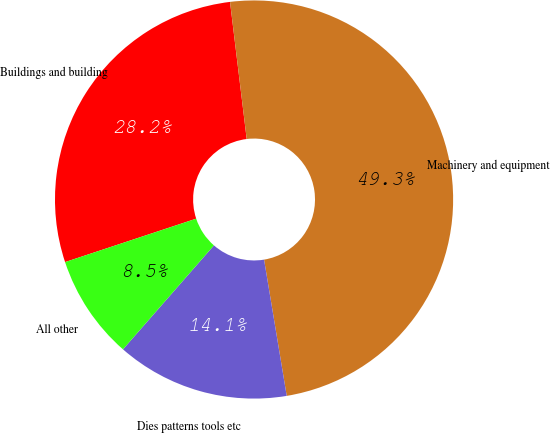Convert chart to OTSL. <chart><loc_0><loc_0><loc_500><loc_500><pie_chart><fcel>Buildings and building<fcel>Machinery and equipment<fcel>Dies patterns tools etc<fcel>All other<nl><fcel>28.16%<fcel>49.3%<fcel>14.06%<fcel>8.47%<nl></chart> 